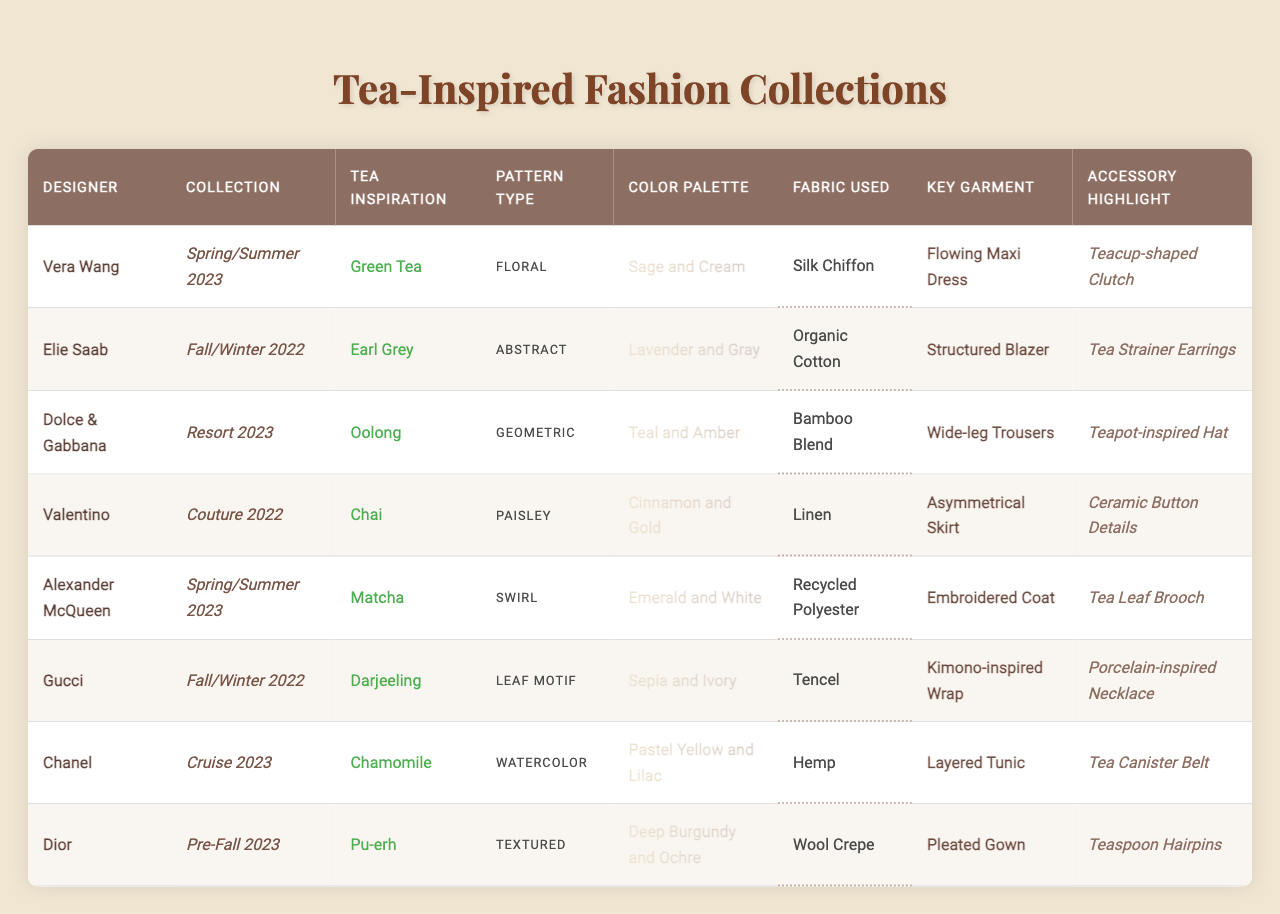What tea inspiration is used by Vera Wang? Vera Wang's tea inspiration in the Spring/Summer 2023 collection is Green Tea, as indicated in the table under the "Tea Inspiration" column.
Answer: Green Tea Which designer features a tea-inspired accessory in their collection? The table lists the accessory highlights for each designer. For instance, Vera Wang features a Teacup-shaped Clutch in her collection.
Answer: Yes What pattern type did Dior use in their Pre-Fall 2023 collection? The pattern type for Dior in the Pre-Fall 2023 collection is listed as Textured in the "Pattern Type" column.
Answer: Textured How many different tea inspirations are represented in the table? There are 8 unique entries under "Tea Inspiration," one for each designer's collection. These inspirations include Green Tea, Earl Grey, Oolong, Chai, Matcha, Darjeeling, Chamomile, and Pu-erh.
Answer: 8 Which color palette corresponds to the Matcha tea inspiration? Matcha tea inspiration is used by Alexander McQueen, whose corresponding color palette is Emerald and White, as shown in the "Color Palette" column.
Answer: Emerald and White What is the total number of silk chiffon garments in the table? Vera Wang's Spring/Summer 2023 collection features a Flowing Maxi Dress made of Silk Chiffon. As there are no other entries listed for silk chiffon, the total count is 1.
Answer: 1 Do any collections feature a paisley pattern? The table shows that Dolce & Gabbana's Resort 2023 collection features a Paisley pattern type. Hence, the answer is affirmative.
Answer: Yes Which designer used both chamomile inspiration and a layered tunic in their collection? According to the table, Chanel used Chamomile as a tea inspiration and highlighted a Layered Tunic for their Cruise 2023 collection. This confirms the combination of these specific elements.
Answer: Chanel What fabric is predominantly used in the collections that include tea leaf brooches as accessories? The table indicates that the accessory highlight "Tea Leaf Brooch" corresponds to the ensemble from Gucci, which features a garment made of Tencel. This is the only relevant fabric associated with that accessory.
Answer: Tencel Who has the darkest color palette and what is it? The designer with the darkest color palette is Dior, using Deep Burgundy and Ochre in their Pre-Fall 2023 collection, as observed under the "Color Palette" column.
Answer: Deep Burgundy and Ochre 